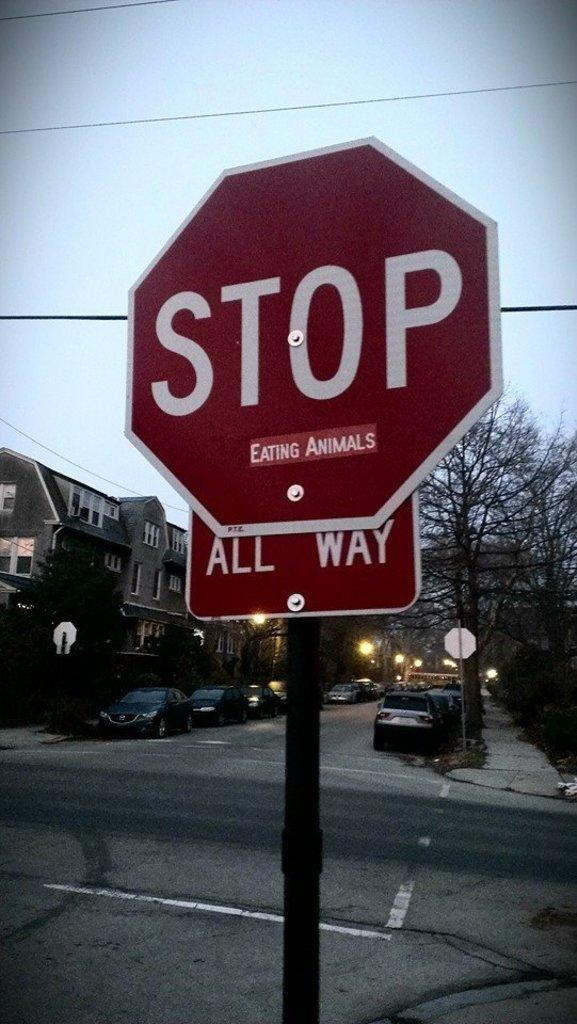<image>
Write a terse but informative summary of the picture. A stop sign under which someone has pasted a sign reading 'eating animals'. 